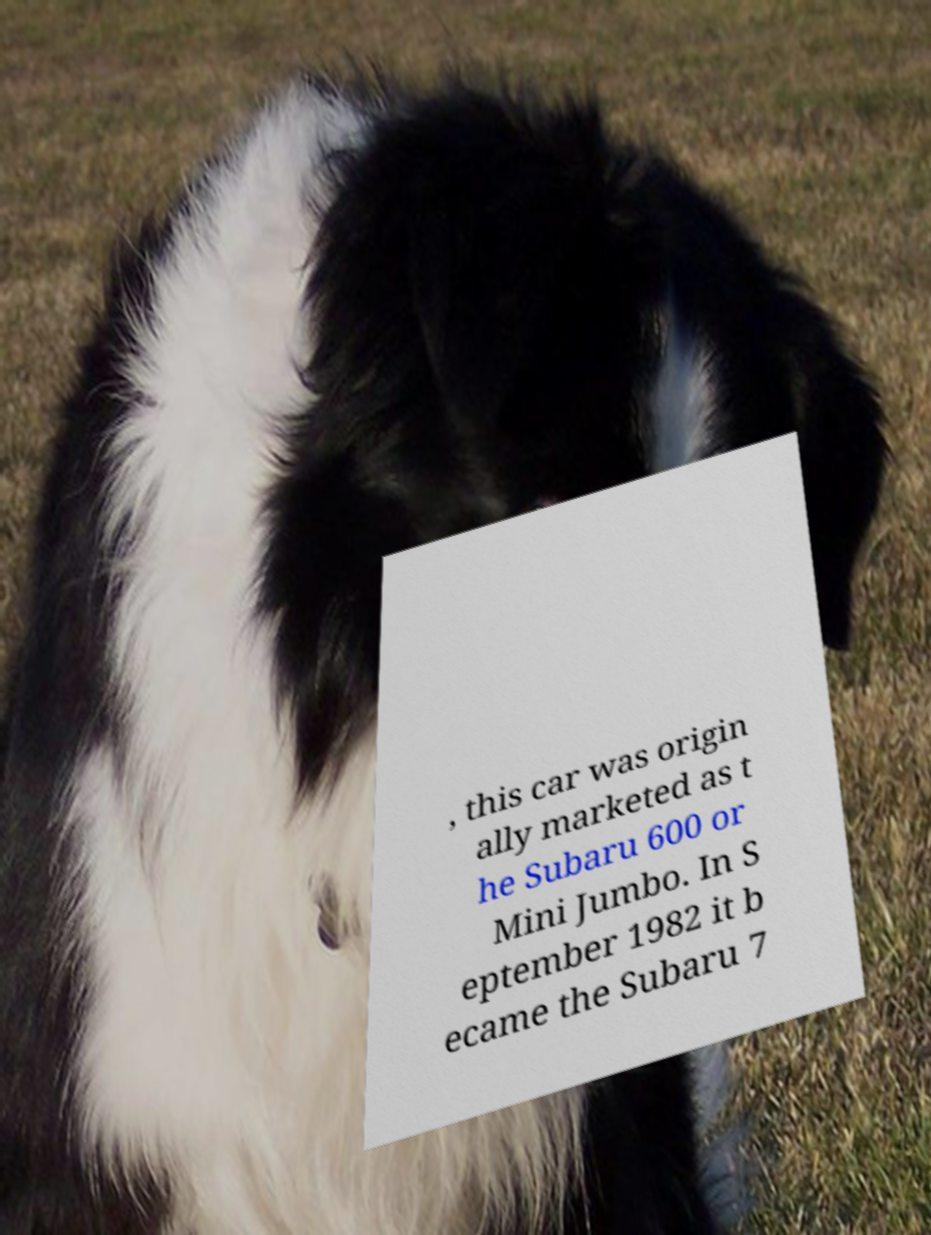Please read and relay the text visible in this image. What does it say? , this car was origin ally marketed as t he Subaru 600 or Mini Jumbo. In S eptember 1982 it b ecame the Subaru 7 